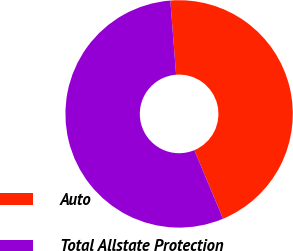Convert chart. <chart><loc_0><loc_0><loc_500><loc_500><pie_chart><fcel>Auto<fcel>Total Allstate Protection<nl><fcel>44.91%<fcel>55.09%<nl></chart> 